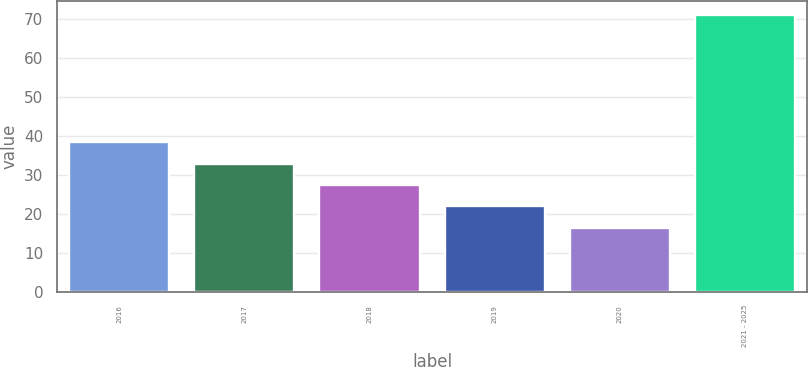<chart> <loc_0><loc_0><loc_500><loc_500><bar_chart><fcel>2016<fcel>2017<fcel>2018<fcel>2019<fcel>2020<fcel>2021 - 2025<nl><fcel>38.38<fcel>32.91<fcel>27.44<fcel>21.97<fcel>16.5<fcel>71.2<nl></chart> 